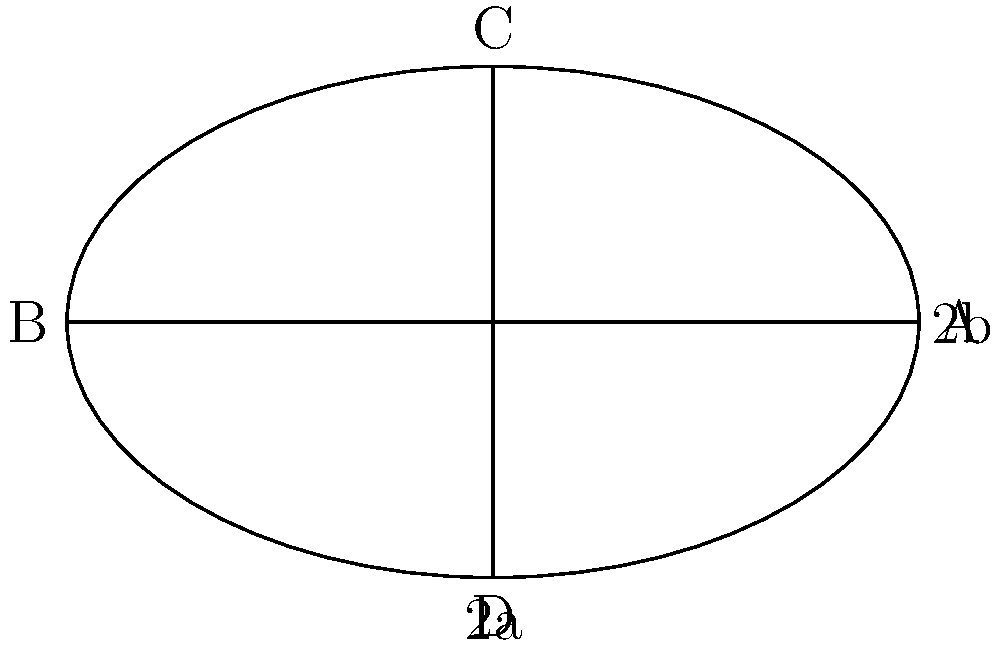You're training on an oval track with dimensions as shown in the figure. The straight parts of the track (AB and its opposite side) measure 100 meters each, while the total length of the curved parts is 200 meters. What is the optimal distance from the inner edge of the track that you should maintain while running to minimize your total distance for one lap? Let's approach this step-by-step:

1) First, we need to understand that the optimal path is one where the runner maintains a constant distance from the inner edge throughout the lap.

2) Let's denote this distance as $r$.

3) The total length of one lap will be the sum of:
   - Two straight parts: $2 \times 100 = 200$ meters
   - Two semicircles with radius $(b+r)$: $2 \times \pi(b+r)$

4) So the total length $L$ is:
   $L = 200 + 2\pi(b+r)$

5) We're told that the total length of the curved parts is 200 meters. This means:
   $2\pi b = 200$
   $b = \frac{100}{\pi}$

6) Substituting this into our equation for $L$:
   $L = 200 + 2\pi(\frac{100}{\pi}+r) = 200 + 200 + 2\pi r = 400 + 2\pi r$

7) To find the optimal $r$, we need to consider the IAAF (International Association of Athletics Federations) rule for track measurements. The IAAF states that races should be measured 30 cm from the inner edge of the track.

8) Therefore, the optimal distance $r$ is 30 cm or 0.3 meters.

9) We can verify this by calculating the total lap distance:
   $L = 400 + 2\pi(0.3) \approx 401.88$ meters

This is indeed very close to the standard 400-meter track used in international competitions.
Answer: 0.3 meters 